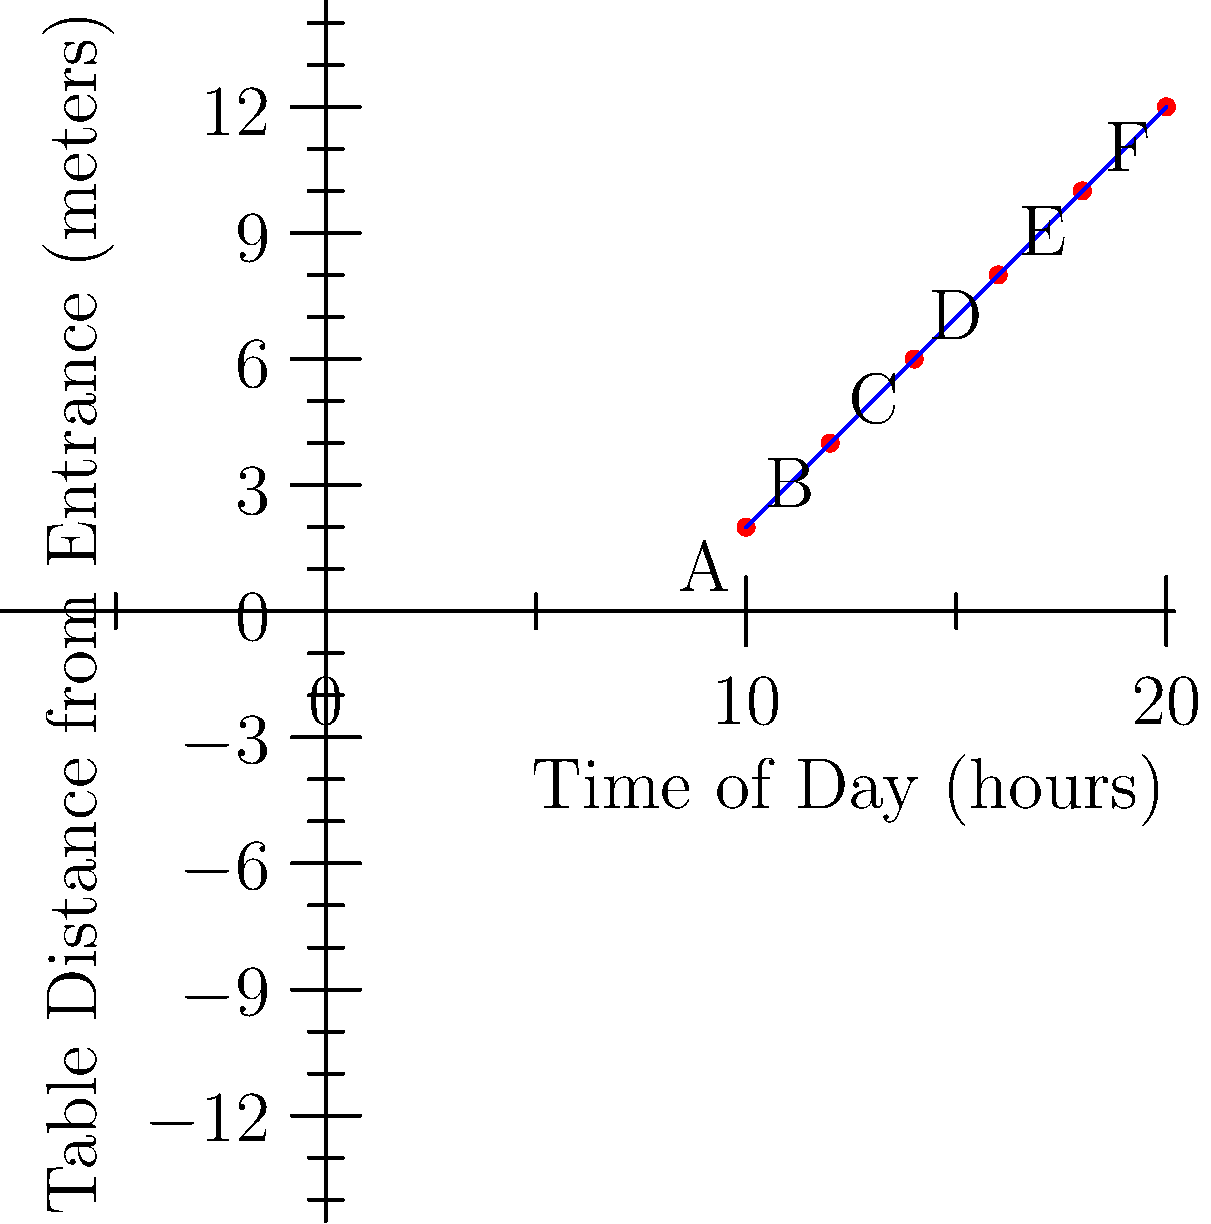The scatter plot shows customer seating preferences in your restaurant throughout the day, with the x-axis representing the time of day (in hours) and the y-axis representing the distance from the entrance (in meters). Points A through F represent different time slots and corresponding average seating distances. What is the rate of change in seating distance preference per hour, and what does this suggest about customer behavior in your restaurant? To solve this problem, we need to follow these steps:

1. Identify the coordinates of the first and last points:
   Point A: (10, 2)
   Point F: (20, 12)

2. Calculate the rate of change using the slope formula:
   $\text{Slope} = \frac{y_2 - y_1}{x_2 - x_1} = \frac{12 - 2}{20 - 10} = \frac{10}{10} = 1$

3. Interpret the result:
   The rate of change is 1 meter per hour.

4. Analyze the customer behavior:
   This positive slope indicates that as the day progresses, customers tend to prefer seating farther from the entrance. This could suggest:
   a) Later in the day, customers may prefer quieter, more private seating options.
   b) There might be a shift from quick, casual dining near the entrance to more leisurely meals farther inside.
   c) The atmosphere of the restaurant may change throughout the day, influencing seating preferences.

5. Consider the implications for the restaurant:
   Understanding this pattern can help with table arrangement, staff allocation, and potentially tailoring the dining experience to match customer preferences at different times of the day.
Answer: 1 meter per hour; customers prefer seating farther from the entrance as the day progresses. 